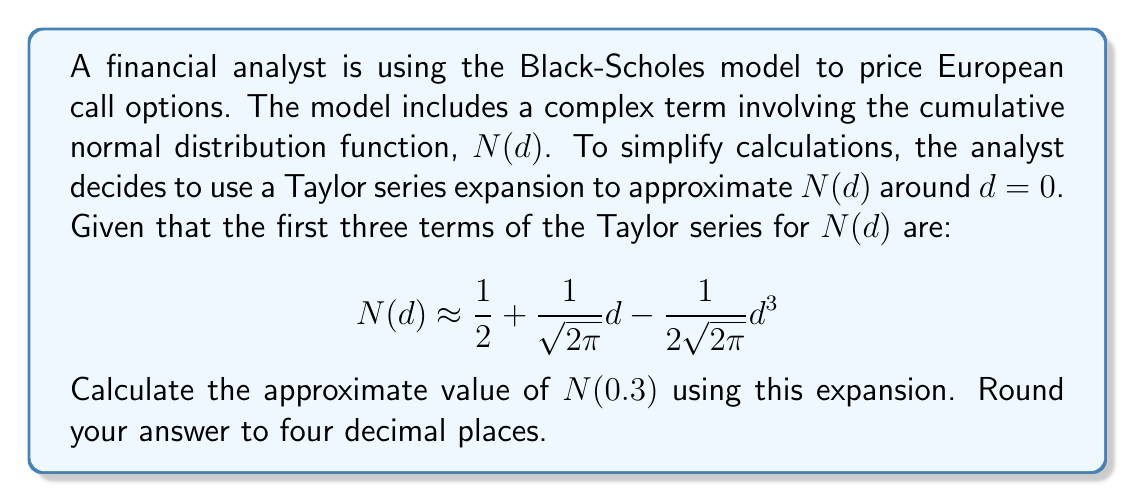Teach me how to tackle this problem. To approximate $N(0.3)$ using the given Taylor series expansion, we'll follow these steps:

1) We have the Taylor series expansion for $N(d)$ around $d=0$:
   $$N(d) \approx \frac{1}{2} + \frac{1}{\sqrt{2\pi}}d - \frac{1}{2\sqrt{2\pi}}d^3$$

2) We need to substitute $d = 0.3$ into this equation:
   $$N(0.3) \approx \frac{1}{2} + \frac{1}{\sqrt{2\pi}}(0.3) - \frac{1}{2\sqrt{2\pi}}(0.3)^3$$

3) Let's calculate each term:
   - First term: $\frac{1}{2} = 0.5$
   - Second term: $\frac{1}{\sqrt{2\pi}}(0.3)$
     $\frac{1}{\sqrt{2\pi}} \approx 0.3989$, so this term is $0.3989 * 0.3 = 0.11967$
   - Third term: $-\frac{1}{2\sqrt{2\pi}}(0.3)^3$
     $-\frac{1}{2\sqrt{2\pi}} \approx -0.19947$, and $(0.3)^3 = 0.027$
     So this term is $-0.19947 * 0.027 = -0.00539$

4) Now, we sum these terms:
   $0.5 + 0.11967 - 0.00539 = 0.61428$

5) Rounding to four decimal places, we get 0.6143.
Answer: 0.6143 